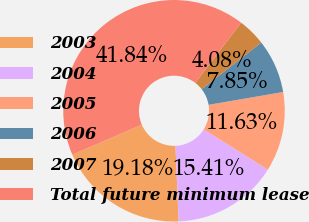Convert chart. <chart><loc_0><loc_0><loc_500><loc_500><pie_chart><fcel>2003<fcel>2004<fcel>2005<fcel>2006<fcel>2007<fcel>Total future minimum lease<nl><fcel>19.18%<fcel>15.41%<fcel>11.63%<fcel>7.85%<fcel>4.08%<fcel>41.84%<nl></chart> 